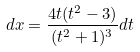<formula> <loc_0><loc_0><loc_500><loc_500>d x = \frac { 4 t ( t ^ { 2 } - 3 ) } { ( t ^ { 2 } + 1 ) ^ { 3 } } d t</formula> 